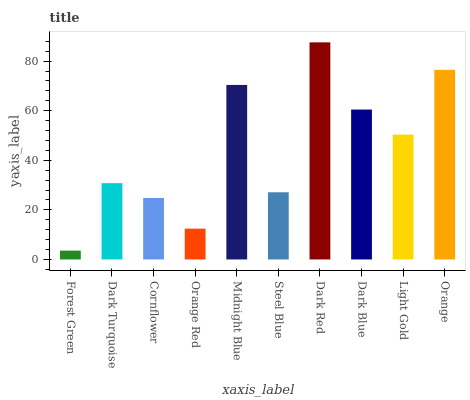Is Forest Green the minimum?
Answer yes or no. Yes. Is Dark Red the maximum?
Answer yes or no. Yes. Is Dark Turquoise the minimum?
Answer yes or no. No. Is Dark Turquoise the maximum?
Answer yes or no. No. Is Dark Turquoise greater than Forest Green?
Answer yes or no. Yes. Is Forest Green less than Dark Turquoise?
Answer yes or no. Yes. Is Forest Green greater than Dark Turquoise?
Answer yes or no. No. Is Dark Turquoise less than Forest Green?
Answer yes or no. No. Is Light Gold the high median?
Answer yes or no. Yes. Is Dark Turquoise the low median?
Answer yes or no. Yes. Is Dark Blue the high median?
Answer yes or no. No. Is Light Gold the low median?
Answer yes or no. No. 